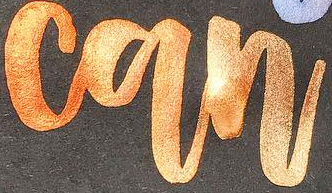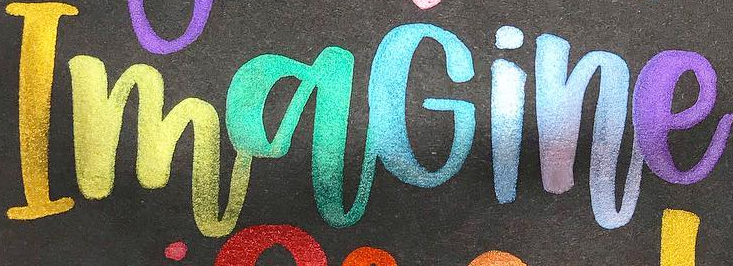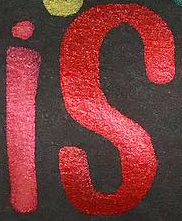Identify the words shown in these images in order, separated by a semicolon. can; ImaGine; is 